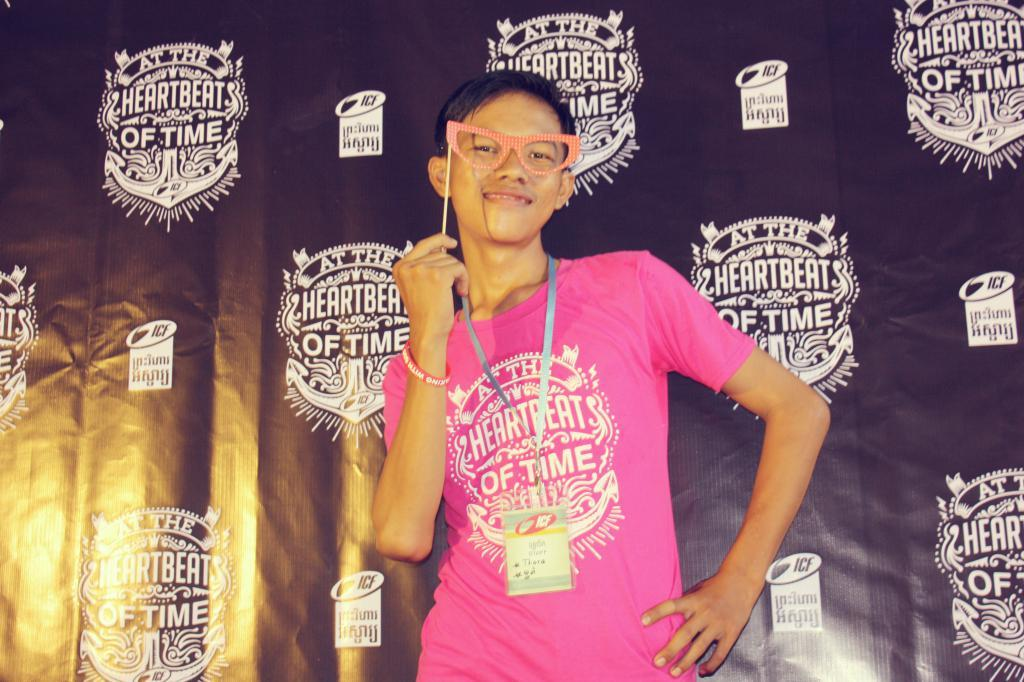What is the main subject of the image? There is a person standing in the middle of the image. What is the person holding in the image? The person is holding an object. What can be seen in the background of the image? There is a wall poster in the background of the image. What type of rod is the person using to hit the cannon in the image? There is no rod or cannon present in the image. How many knives can be seen in the image? There are no knives present in the image. 